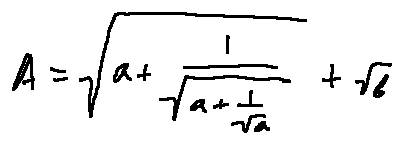<formula> <loc_0><loc_0><loc_500><loc_500>A = \sqrt { a + \frac { 1 } { \sqrt { a + \frac { 1 } { \sqrt { a } } } } } + \sqrt { b }</formula> 